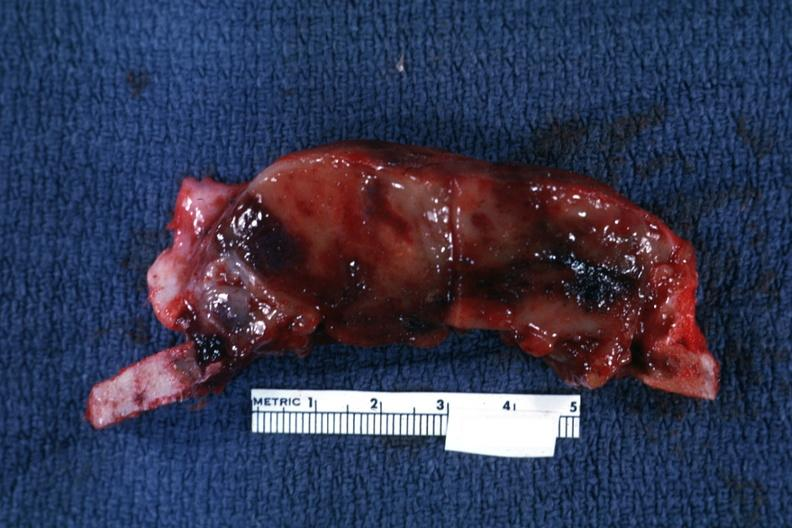s teeth present?
Answer the question using a single word or phrase. No 